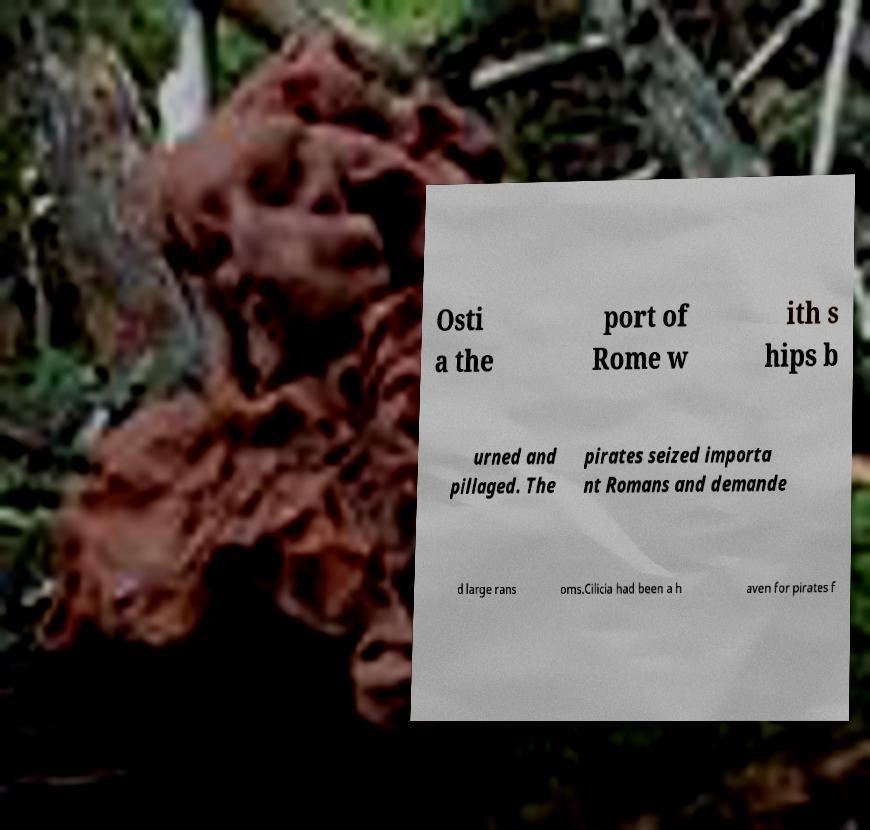Please identify and transcribe the text found in this image. Osti a the port of Rome w ith s hips b urned and pillaged. The pirates seized importa nt Romans and demande d large rans oms.Cilicia had been a h aven for pirates f 